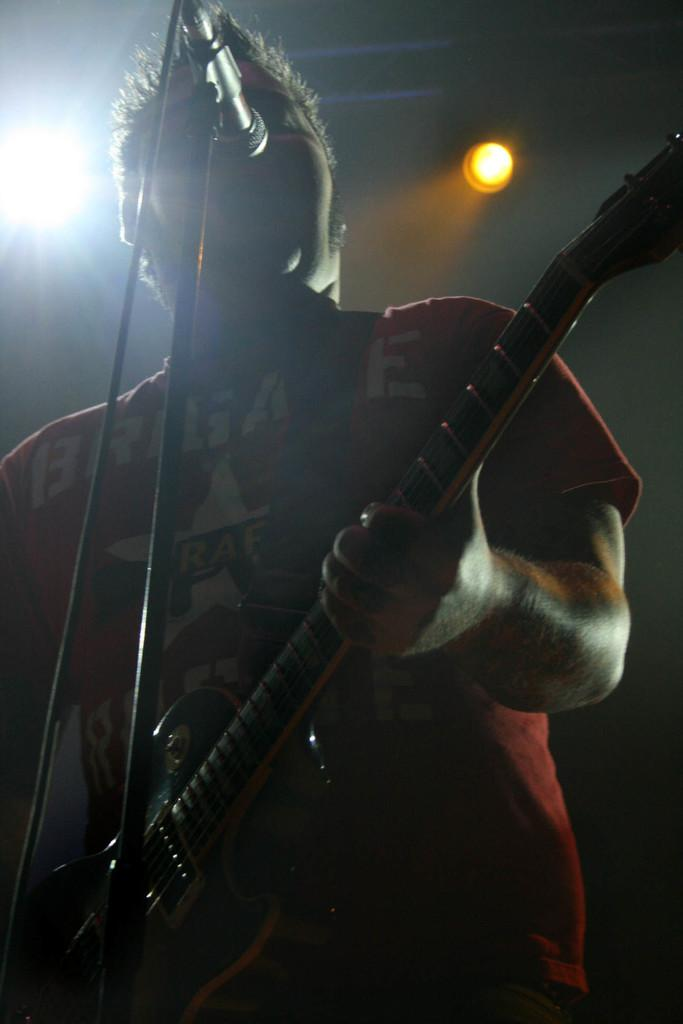Who is the main subject in the image? There is a man in the image. What is the man doing in the image? The man is standing and playing a guitar. What object is present in the image that is typically used for amplifying sound? There is a microphone in the image. How many eggs are visible in the image? There are no eggs present in the image. What type of agreement is being discussed by the man in the image? The image does not show any discussion or agreement; it only depicts a man playing a guitar and a microphone. 